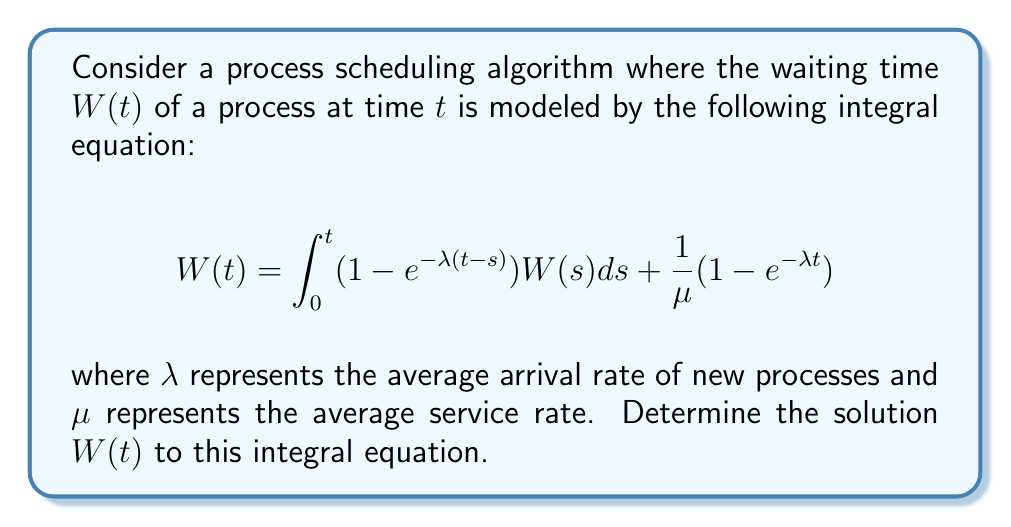Could you help me with this problem? To solve this integral equation, we'll use the Laplace transform method:

1) Take the Laplace transform of both sides of the equation:
   $$\mathcal{L}\{W(t)\} = \mathcal{L}\{\int_0^t (1 - e^{-\lambda(t-s)})W(s)ds\} + \mathcal{L}\{\frac{1}{\mu}(1 - e^{-\lambda t})\}$$

2) Let $\mathcal{L}\{W(t)\} = \tilde{W}(p)$. Using the convolution theorem and Laplace transform properties:
   $$\tilde{W}(p) = (1 - \frac{\lambda}{p+\lambda})\tilde{W}(p) + \frac{1}{\mu}(\frac{1}{p} - \frac{1}{p+\lambda})$$

3) Simplify and solve for $\tilde{W}(p)$:
   $$\tilde{W}(p) = \frac{\lambda}{p(p+\lambda-\lambda)} \cdot \frac{1}{\mu} = \frac{\lambda}{\mu p^2}$$

4) Take the inverse Laplace transform:
   $$W(t) = \mathcal{L}^{-1}\{\frac{\lambda}{\mu p^2}\} = \frac{\lambda}{\mu}t$$

This solution represents the average waiting time of a process as a linear function of time, with the slope determined by the ratio of arrival rate to service rate.
Answer: $W(t) = \frac{\lambda}{\mu}t$ 